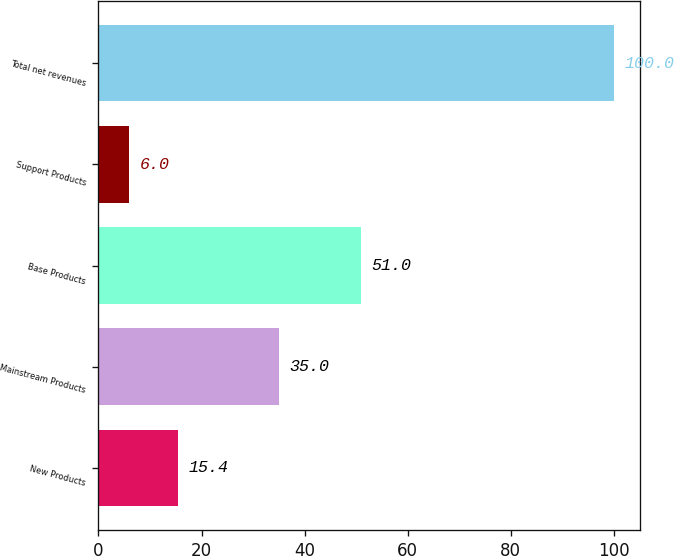<chart> <loc_0><loc_0><loc_500><loc_500><bar_chart><fcel>New Products<fcel>Mainstream Products<fcel>Base Products<fcel>Support Products<fcel>Total net revenues<nl><fcel>15.4<fcel>35<fcel>51<fcel>6<fcel>100<nl></chart> 